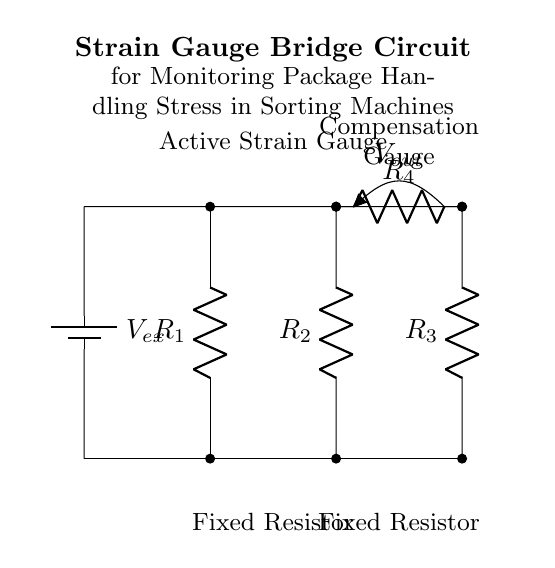What type of circuit is this? This diagram represents a strain gauge bridge circuit, which is a specific arrangement used to measure small changes in resistance typically caused by strain in a material. This circuit is characterized by its balanced resistor configuration, forming a bridge.
Answer: Strain gauge bridge What are the values of the resistors in this circuit? The resistors in this circuit are labeled as R1, R2, R3, and R4 but their numerical values are not specified in the diagram itself. Therefore, we cannot infer the specific resistance values from the diagram.
Answer: Not specified What is the purpose of the active strain gauge? The active strain gauge is used to detect changes in strain, translating physical deformation into a measurable electrical signal. This enables the monitoring of stress experienced by packages during sorting.
Answer: Measure strain What are the components in the side of the bridge? The components in the side of the bridge are R1 and R3. These components provide the fixed resistance that balances the bridge and helps in precise measurement of strain.
Answer: R1 and R3 How is the output voltage represented? The output voltage is represented as Vout and is positioned across the bridge output, indicating the potential difference generated due to changes in resistance. This voltage is crucial for measuring the strain experienced by the material.
Answer: Vout What does the voltage source represent? The voltage source, represented as Vex in this circuit, provides the necessary excitation voltage for the strain gauges in the bridge to operate, ensuring they have the initial voltage required for strain measurement.
Answer: Vex What is the function of the compensation gauge? The compensation gauge helps to negate temperature effects and other environmental variations on resistance measurements, ensuring that any output signal is primarily due to the measured strain rather than external factors.
Answer: Negate variations 